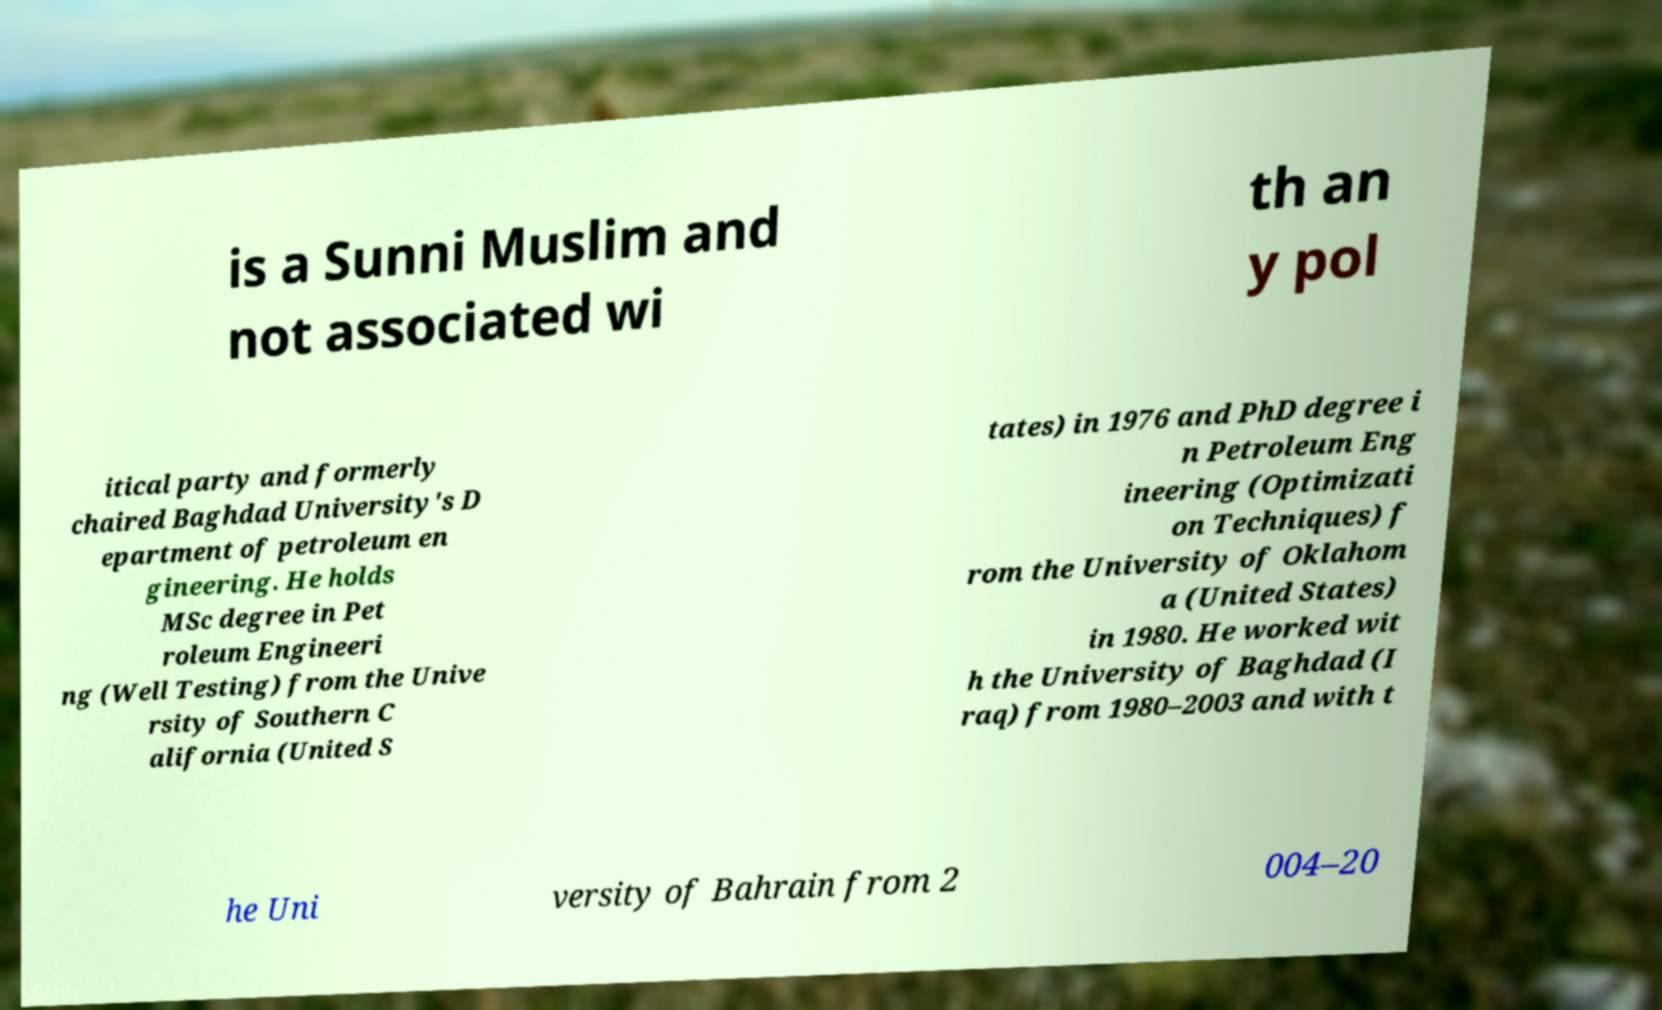Could you assist in decoding the text presented in this image and type it out clearly? is a Sunni Muslim and not associated wi th an y pol itical party and formerly chaired Baghdad University's D epartment of petroleum en gineering. He holds MSc degree in Pet roleum Engineeri ng (Well Testing) from the Unive rsity of Southern C alifornia (United S tates) in 1976 and PhD degree i n Petroleum Eng ineering (Optimizati on Techniques) f rom the University of Oklahom a (United States) in 1980. He worked wit h the University of Baghdad (I raq) from 1980–2003 and with t he Uni versity of Bahrain from 2 004–20 